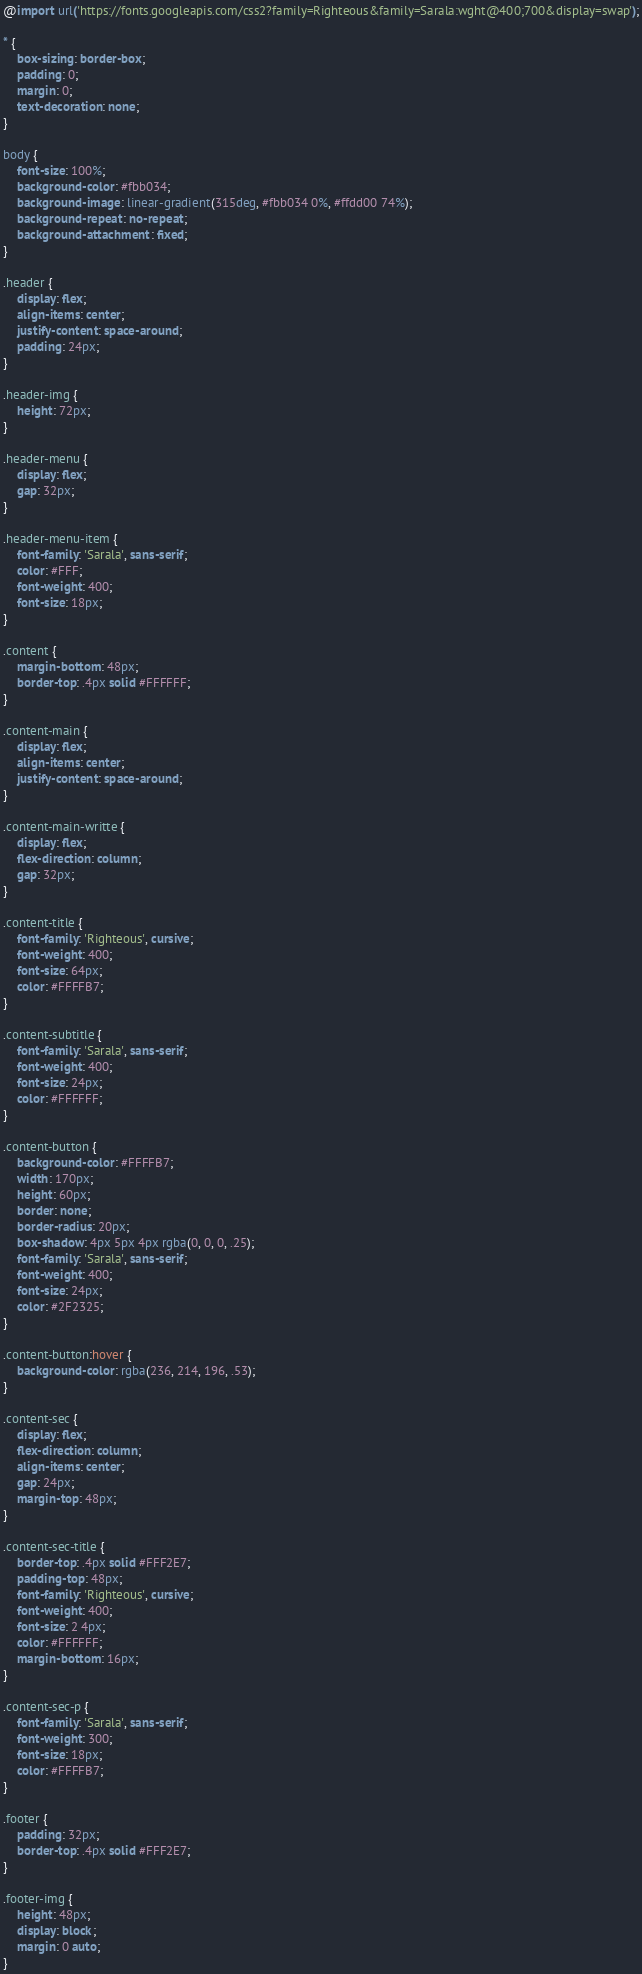<code> <loc_0><loc_0><loc_500><loc_500><_CSS_>@import url('https://fonts.googleapis.com/css2?family=Righteous&family=Sarala:wght@400;700&display=swap');

* {
    box-sizing: border-box;
    padding: 0;
    margin: 0;
    text-decoration: none;
}

body {
    font-size: 100%;
    background-color: #fbb034;
    background-image: linear-gradient(315deg, #fbb034 0%, #ffdd00 74%);
    background-repeat: no-repeat;
    background-attachment: fixed;
}

.header {
    display: flex;
    align-items: center;
    justify-content: space-around;
    padding: 24px;
}

.header-img {
    height: 72px;
}

.header-menu {
    display: flex;
    gap: 32px;
}

.header-menu-item {
    font-family: 'Sarala', sans-serif;
    color: #FFF;
    font-weight: 400;
    font-size: 18px;
}

.content { 
    margin-bottom: 48px;
    border-top: .4px solid #FFFFFF;
}

.content-main {
    display: flex;
    align-items: center;
    justify-content: space-around;
}

.content-main-writte {
    display: flex;
    flex-direction: column;
    gap: 32px;
}

.content-title {
    font-family: 'Righteous', cursive;
    font-weight: 400;
    font-size: 64px;
    color: #FFFFB7;
}

.content-subtitle {
    font-family: 'Sarala', sans-serif;
    font-weight: 400;
    font-size: 24px;
    color: #FFFFFF;
}

.content-button {
    background-color: #FFFFB7;
    width: 170px;
    height: 60px;
    border: none;
    border-radius: 20px;
    box-shadow: 4px 5px 4px rgba(0, 0, 0, .25);
    font-family: 'Sarala', sans-serif;
    font-weight: 400;
    font-size: 24px;
    color: #2F2325;
}

.content-button:hover {
    background-color: rgba(236, 214, 196, .53);
}

.content-sec {
    display: flex;
    flex-direction: column;
    align-items: center;
    gap: 24px;
    margin-top: 48px;
}

.content-sec-title {
    border-top: .4px solid #FFF2E7;
    padding-top: 48px;
    font-family: 'Righteous', cursive;
    font-weight: 400;
    font-size: 2 4px;
    color: #FFFFFF;
    margin-bottom: 16px;
}

.content-sec-p {
    font-family: 'Sarala', sans-serif;
    font-weight: 300;
    font-size: 18px;
    color: #FFFFB7;
}

.footer {
    padding: 32px;
    border-top: .4px solid #FFF2E7;
}

.footer-img {
    height: 48px;
    display: block;
    margin: 0 auto;
}</code> 